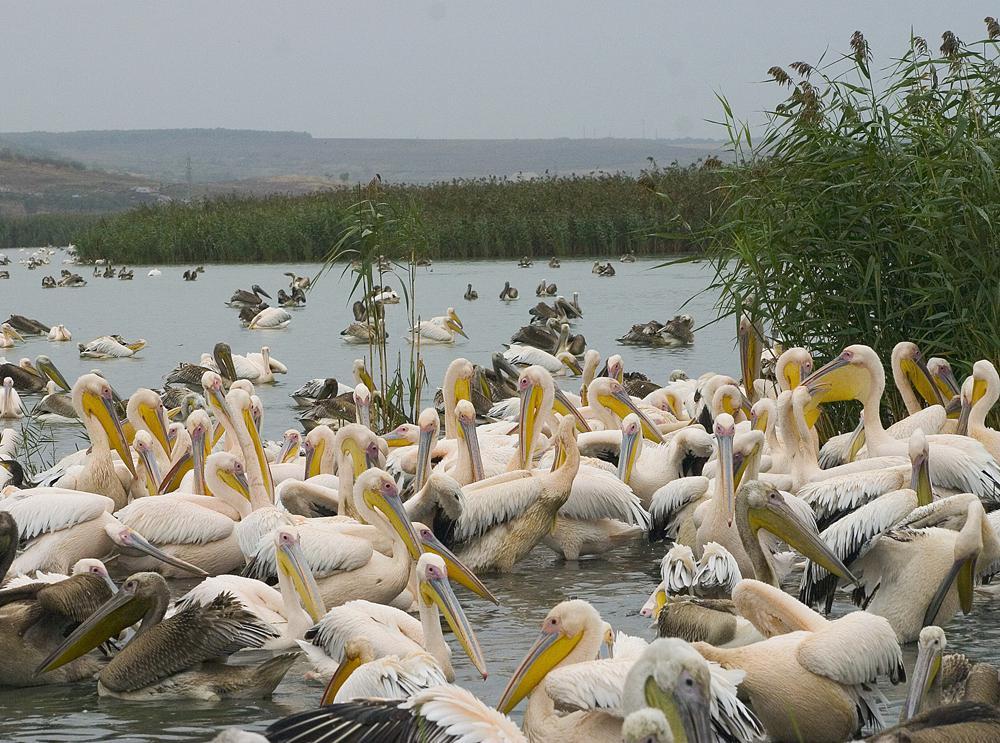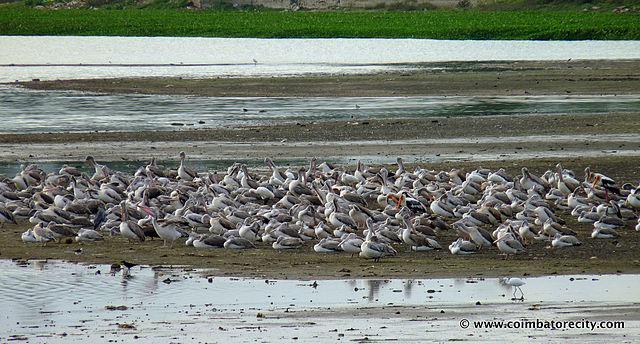The first image is the image on the left, the second image is the image on the right. For the images displayed, is the sentence "Birds are all in a group on an area of dry ground surrounded by water, in one image." factually correct? Answer yes or no. Yes. 